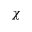Convert formula to latex. <formula><loc_0><loc_0><loc_500><loc_500>\chi</formula> 